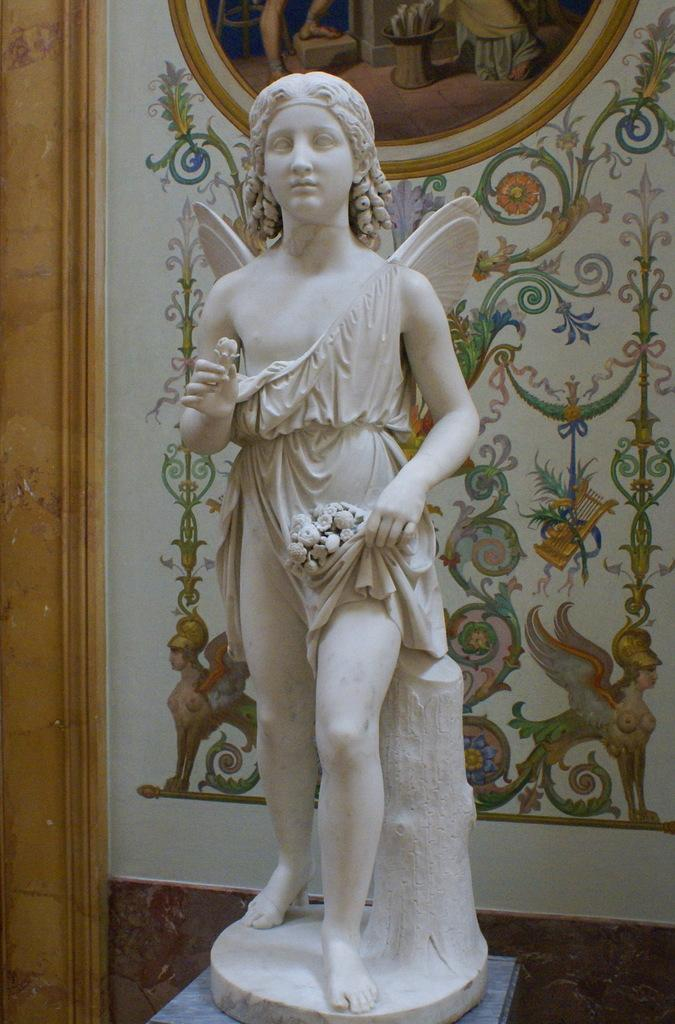What is the main subject of the image? There is a sculpture of a person in the image. What is located behind the sculpture? There is a wall behind the sculpture. How many women are visible in the image? There are no women visible in the image; it features a sculpture of a person. What type of tax can be seen being collected in the image? There is no tax being collected in the image; it features a sculpture of a person and a wall. 